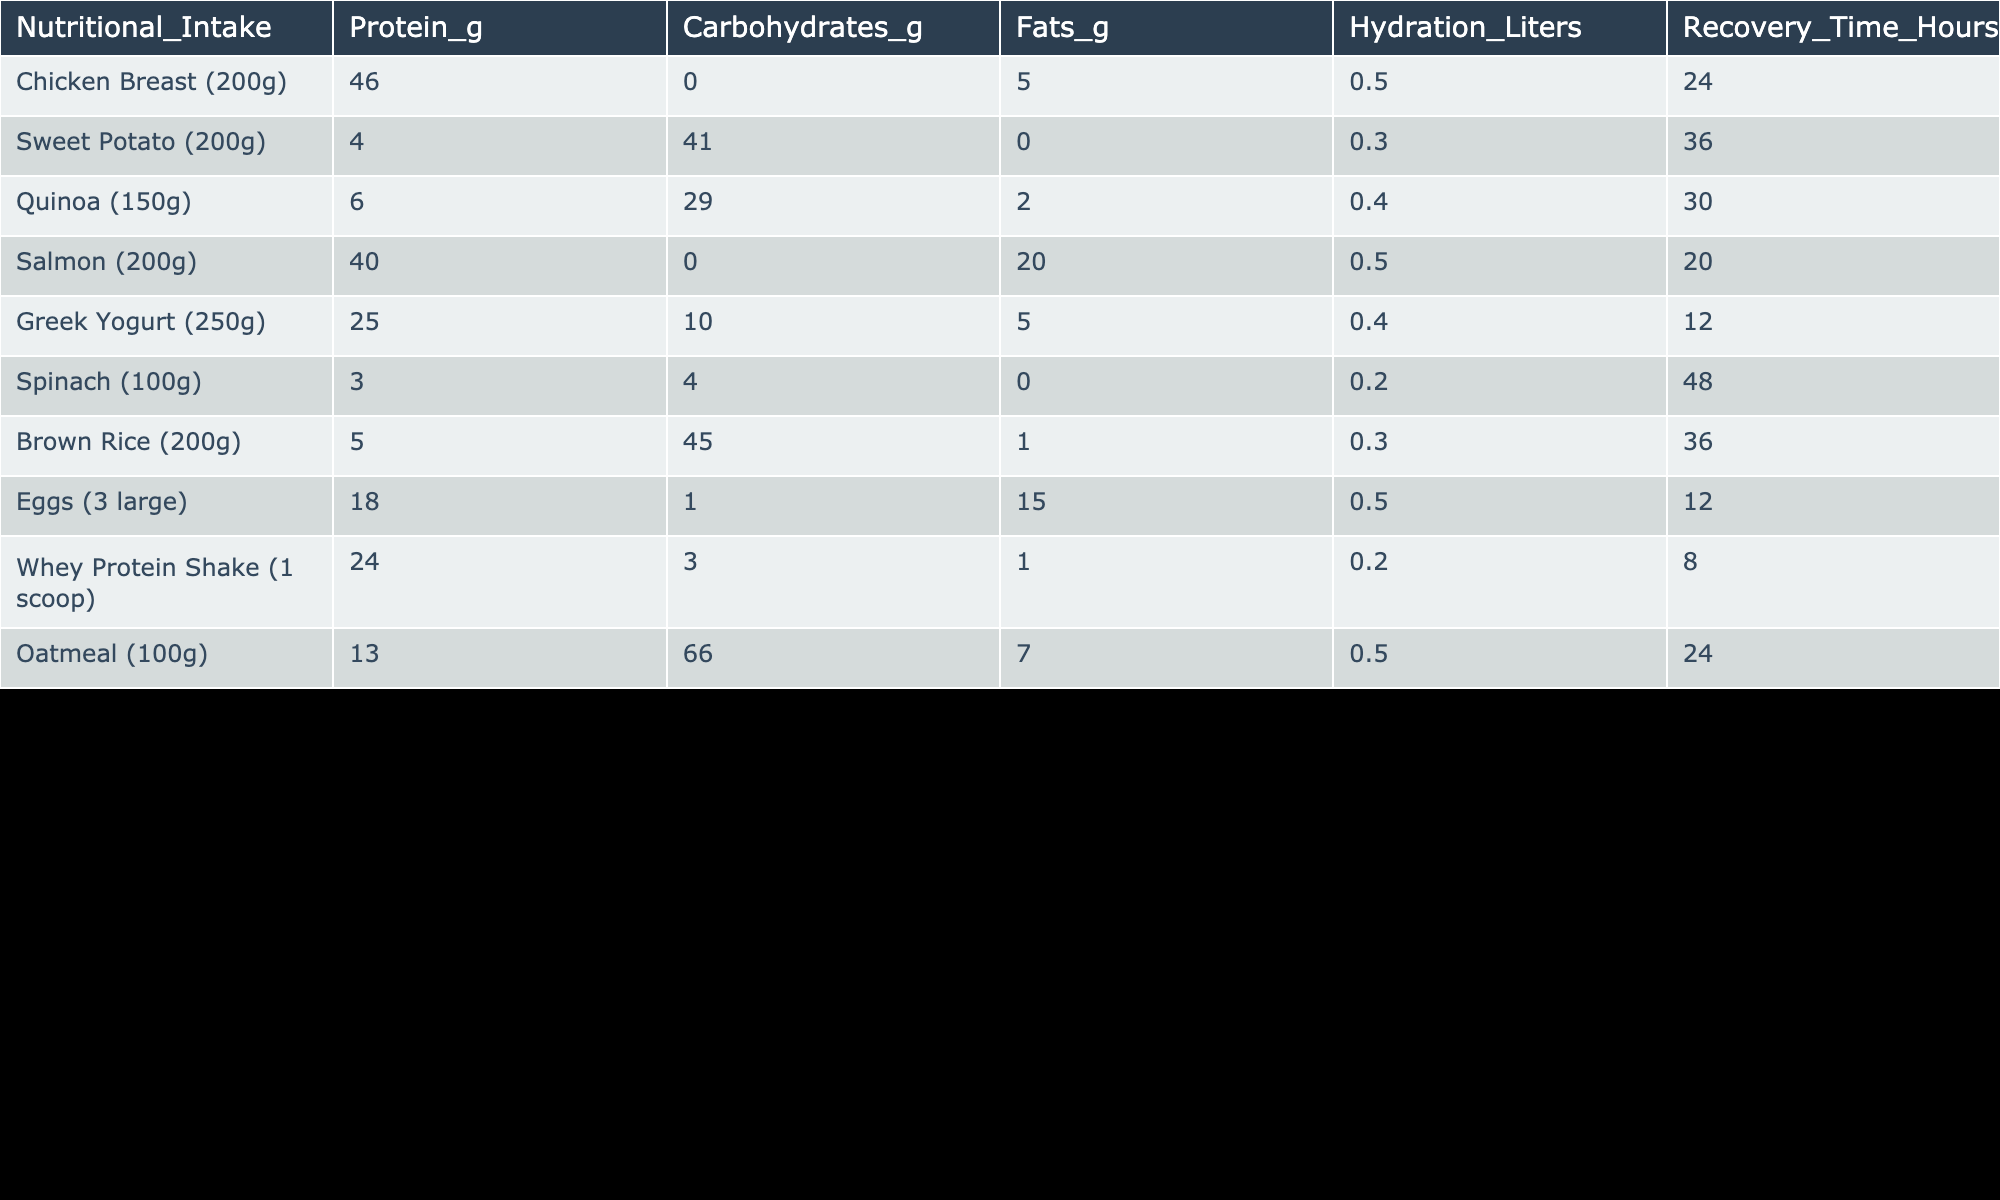What is the protein content in the Chicken Breast? The table shows the nutritional intake values for various foods. For Chicken Breast, the Protein value is listed as 46 grams.
Answer: 46 grams Which food has the highest recovery time? By comparing the Recovery Time values in the table, Spinach has the highest recovery time of 48 hours.
Answer: 48 hours How many grams of carbohydrates are in Oatmeal? The table lists Oatmeal under Nutritional Intake, showing that it contains 66 grams of carbohydrates.
Answer: 66 grams What is the average protein content among all the foods listed? To find the average protein content, sum the protein values: (46 + 4 + 6 + 40 + 25 + 3 + 5 + 18 + 24 + 13) = 184. There are 10 entries, so the average is 184/10 = 18.4 grams.
Answer: 18.4 grams Does Greek Yogurt have more fats than Sweet Potato? Comparing the fats content, Greek Yogurt has 5 grams of fats while Sweet Potato has 0 grams. Therefore, Greek Yogurt does have more fats than Sweet Potato.
Answer: Yes Which food combination provides the least hydration and fastest recovery time? Checking the table, the Whey Protein Shake has 0.2 liters of hydration and the shortest recovery time of 8 hours.
Answer: Whey Protein Shake Is the recovery time of Salmon shorter than that of Chicken Breast? The recovery time for Salmon is 20 hours, and for Chicken Breast, it is 24 hours. Since 20 is less than 24, the statement is true.
Answer: Yes What is the total fat content of the foods that have a protein content greater than 20 grams? The foods with protein greater than 20 grams are Chicken Breast (5g), Salmon (20g), Greek Yogurt (5g), Eggs (15g), and Whey Protein Shake (1g). The total fats from these are 5 + 20 + 5 + 15 + 1 = 46 grams.
Answer: 46 grams Which food item has the second highest protein content? Arranging the protein values in descending order, Chicken Breast (46g), Salmon (40g), and Whey Protein Shake (24g) means that Salmon has the second highest protein content of 40 grams.
Answer: 40 grams 